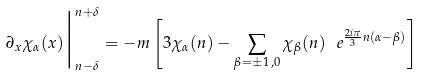<formula> <loc_0><loc_0><loc_500><loc_500>\partial _ { x } \chi _ { \alpha } ( x ) \Big | _ { n - \delta } ^ { n + \delta } = - m \left [ 3 \chi _ { \alpha } ( n ) - \sum _ { \beta = \pm 1 \, , 0 } \chi _ { \beta } ( n ) \, \ e ^ { \frac { 2 i \pi } { 3 } n ( \alpha - \beta ) } \right ]</formula> 